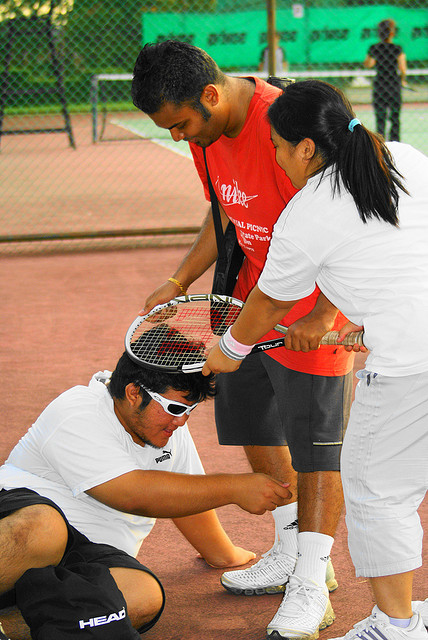How many people are wearing sunglasses? There is one person wearing sunglasses in the image. He is engaged in a group activity on a tennis court, showing the sunglasses are not only a fashion choice but also a practical item for outdoor sports. 